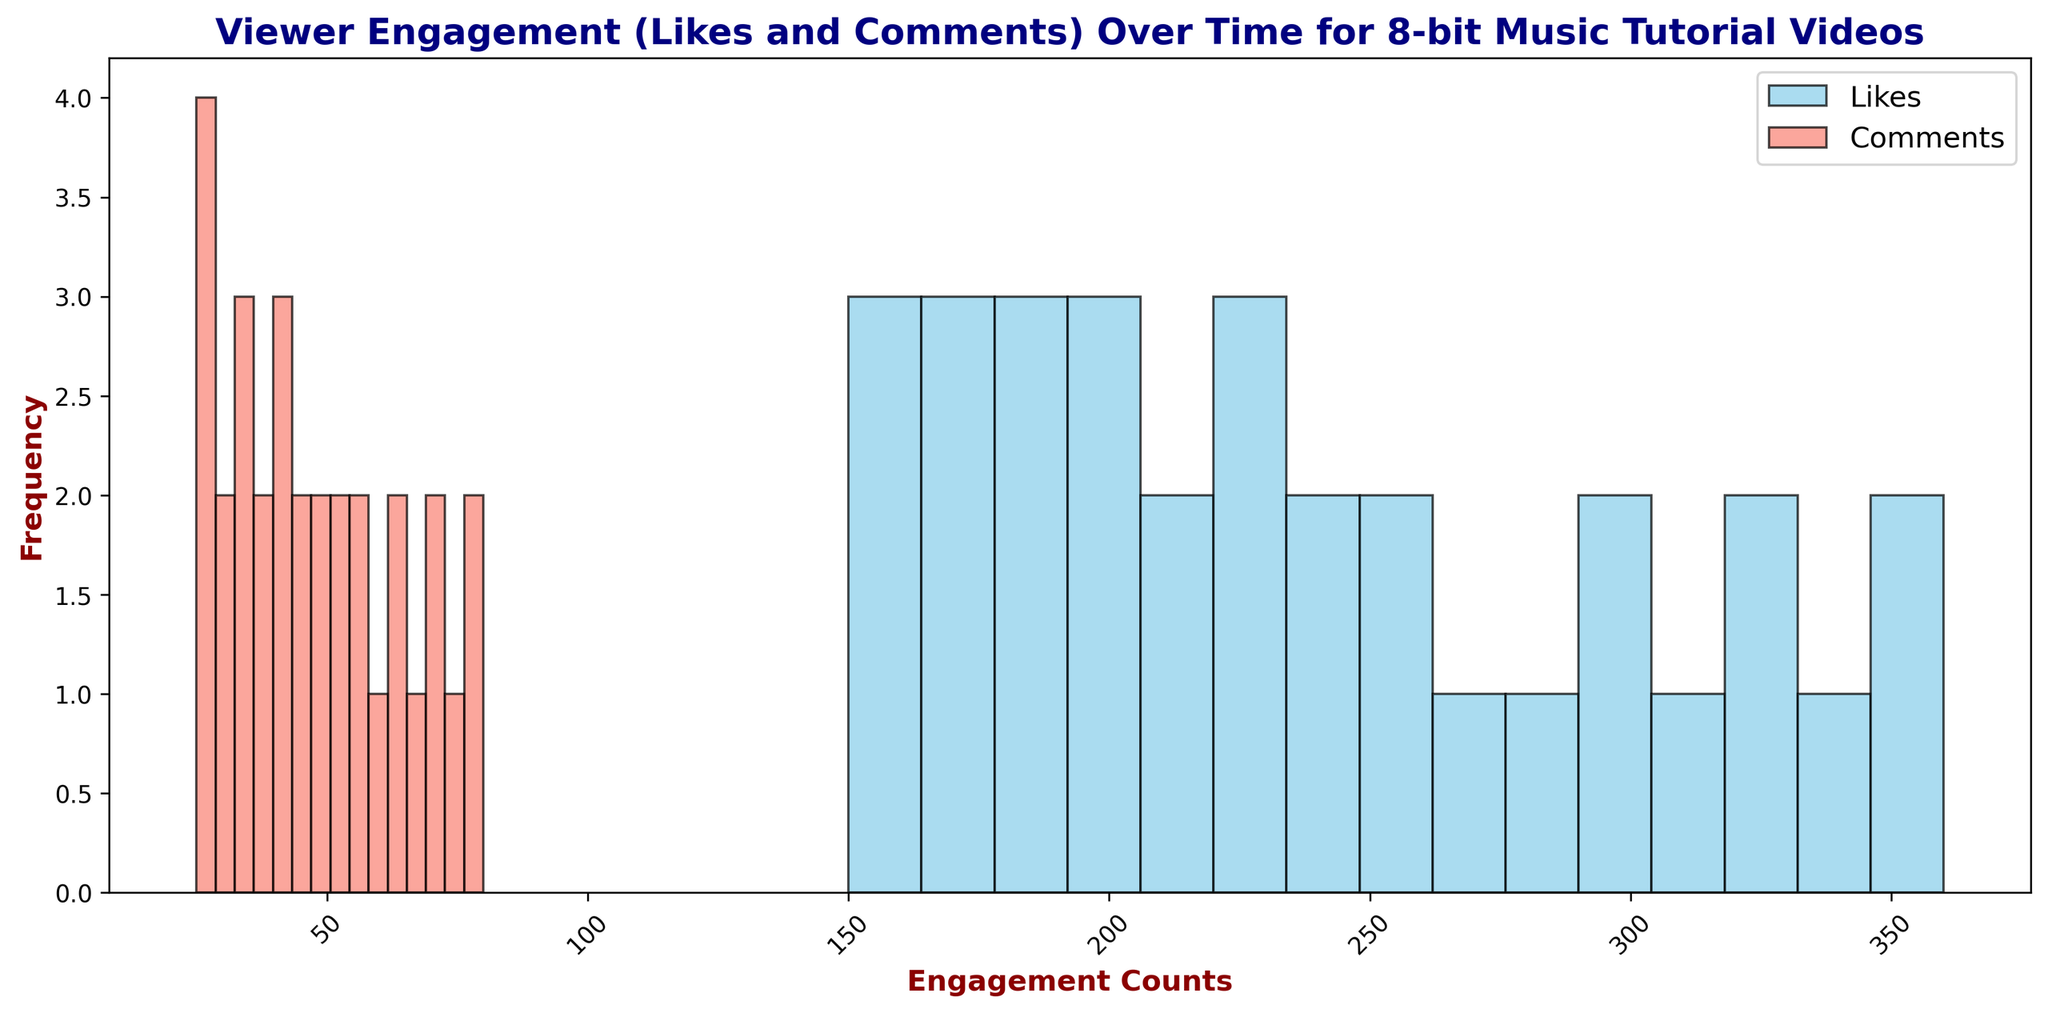What does the title of the histogram tell us? The title of the histogram provides an overall description of the data being visualized. It specifies that the histogram shows viewer engagement, specifically likes and comments, over time for 8-bit music tutorial videos.
Answer: Viewer engagement over time for 8-bit music tutorial videos Which color represents the likes in the histogram? The legend in the histogram indicates that the color representing likes is a sky blue.
Answer: Sky blue Which color represents the comments in the histogram? The legend in the histogram indicates that the color representing comments is salmon.
Answer: Salmon How many bins are used to plot the histogram for likes? By examining the histogram, we see that the x-axis is divided into 15 sections for the likes data.
Answer: 15 How many bins are used to plot the histogram for comments? By looking at the x-axis divisions for the comments, it is also divided into 15 sections.
Answer: 15 Is the frequency of likes generally higher or lower than comments? By observing the heights of the bars in the histogram, the bars for likes are generally higher than those for comments. This indicates the frequency of likes is generally higher.
Answer: Higher What’s the mode value range for likes? The mode value range for likes is found by locating the bin with the highest bar. The tallest bar in the histogram of the likes appears between 200-220.
Answer: 200-220 What range of engagement counts is the most common for comments? The most common range for comments is identified by locating the highest bar in that part of the histogram, which appears to be between 50-60.
Answer: 50-60 Compare the frequency of likes between the ranges 200-220 and 320-340. To compare these ranges, look at the bar heights for likes within these ranges. The bars for 200-220 are taller than those for 320-340, indicating a higher frequency for the range 200-220.
Answer: 200-220 > 320-340 Which range of likes has the lowest frequency? The range of likes with the lowest frequency can be identified by locating the shortest bar in the histogram of likes, which is the 150-170 range.
Answer: 150-170 